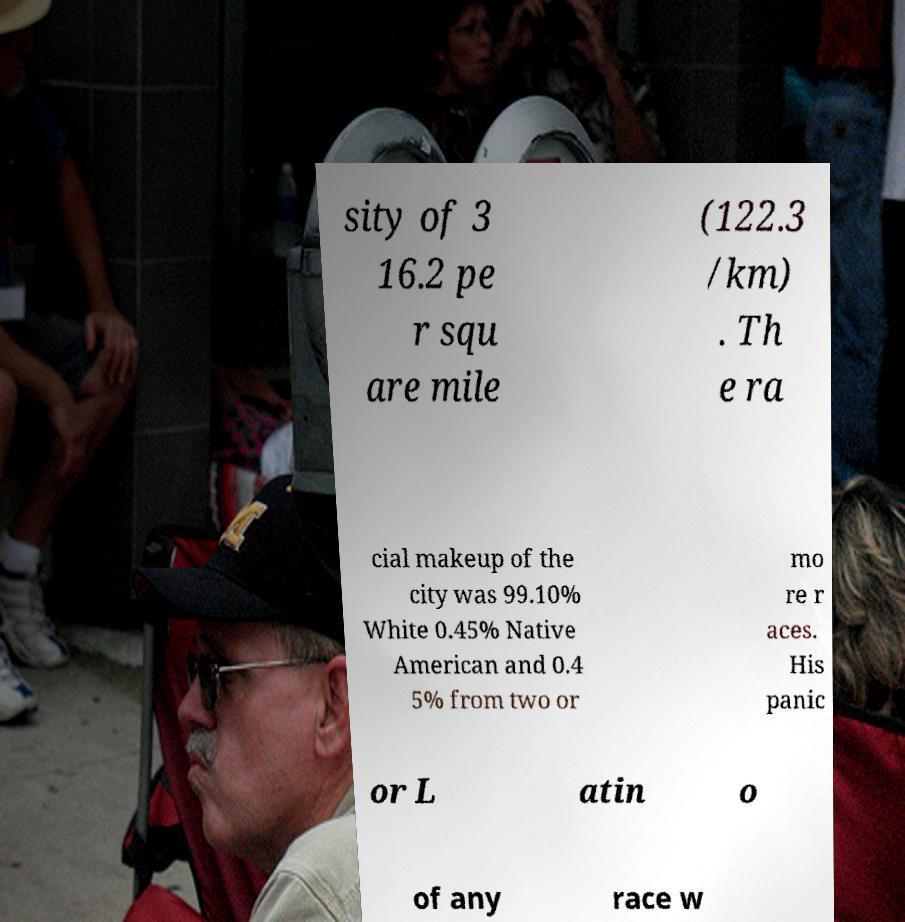I need the written content from this picture converted into text. Can you do that? sity of 3 16.2 pe r squ are mile (122.3 /km) . Th e ra cial makeup of the city was 99.10% White 0.45% Native American and 0.4 5% from two or mo re r aces. His panic or L atin o of any race w 